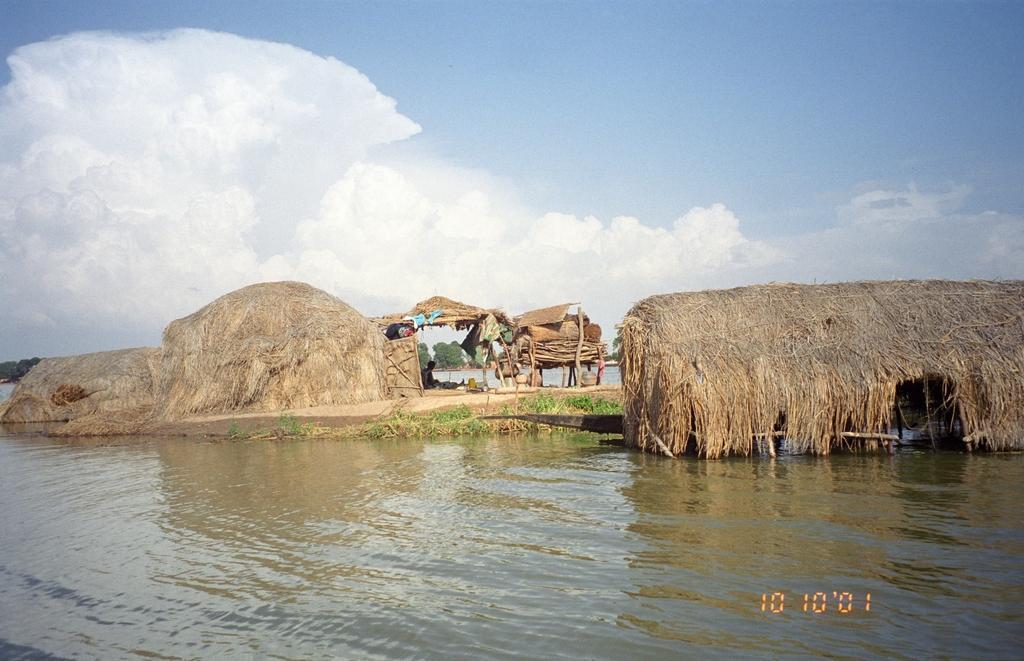How would you summarize this image in a sentence or two? In this image I can see hits, the water and other objects on the ground. In the background I can see the sky. Here I can see a watermark on the image. 